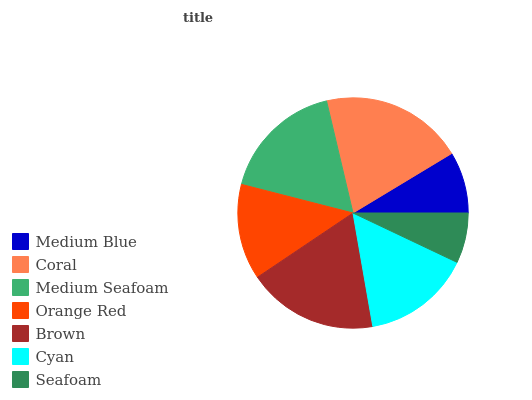Is Seafoam the minimum?
Answer yes or no. Yes. Is Coral the maximum?
Answer yes or no. Yes. Is Medium Seafoam the minimum?
Answer yes or no. No. Is Medium Seafoam the maximum?
Answer yes or no. No. Is Coral greater than Medium Seafoam?
Answer yes or no. Yes. Is Medium Seafoam less than Coral?
Answer yes or no. Yes. Is Medium Seafoam greater than Coral?
Answer yes or no. No. Is Coral less than Medium Seafoam?
Answer yes or no. No. Is Cyan the high median?
Answer yes or no. Yes. Is Cyan the low median?
Answer yes or no. Yes. Is Coral the high median?
Answer yes or no. No. Is Orange Red the low median?
Answer yes or no. No. 